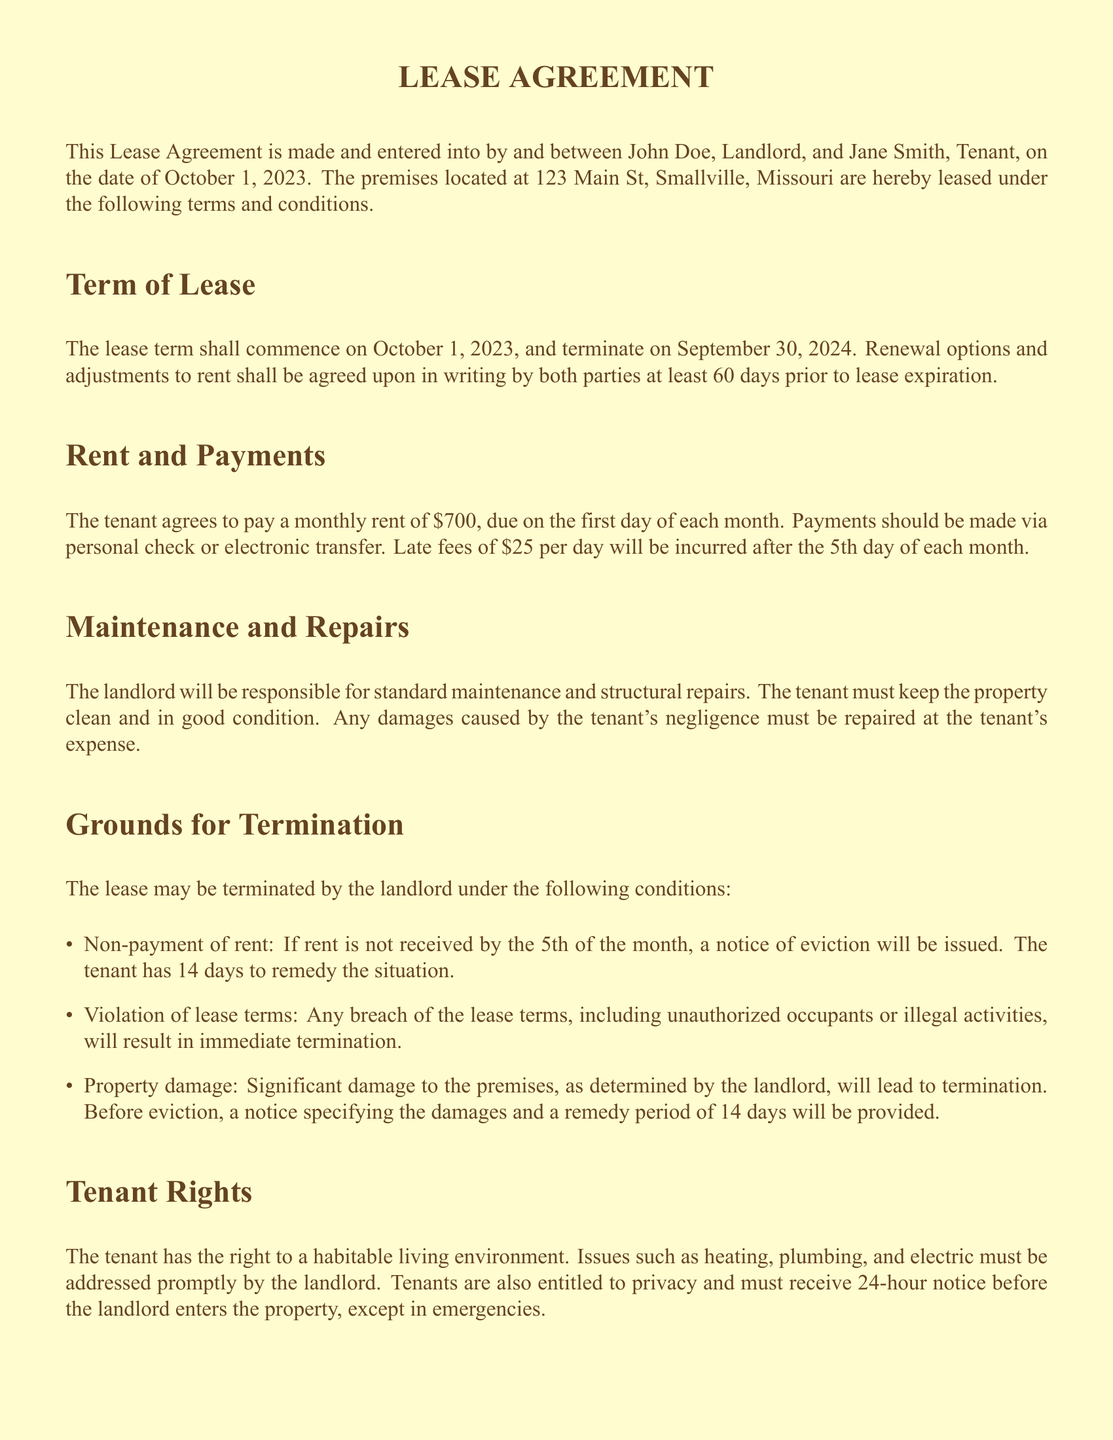What is the name of the landlord? The landlord is named at the beginning of the lease agreement.
Answer: John Doe What is the monthly rent amount? The lease specifies the monthly rent that the tenant must pay.
Answer: $700 What is the termination date of the lease? The lease term's end date is mentioned in the document.
Answer: September 30, 2024 How many days does the tenant have to remedy non-payment of rent? The document outlines a specific period for remedying non-payment of rent.
Answer: 14 days What must the landlord provide before entering the property? The lease specifies the notice requirement for the landlord regarding entry.
Answer: 24-hour notice What grounds can lead to immediate termination of the lease? The document lists specific reasons that can lead to lease termination.
Answer: Violation of lease terms What action must the landlord take to initiate eviction? The lease outlines the initial step in the eviction process.
Answer: File a formal complaint What is required for modifications to the lease agreement? The lease states how modifications must be documented.
Answer: In writing and signed by both parties What environmental requirement does the lease ensure for tenants? The document states a specific entitlement regarding living conditions.
Answer: Habitable living environment 